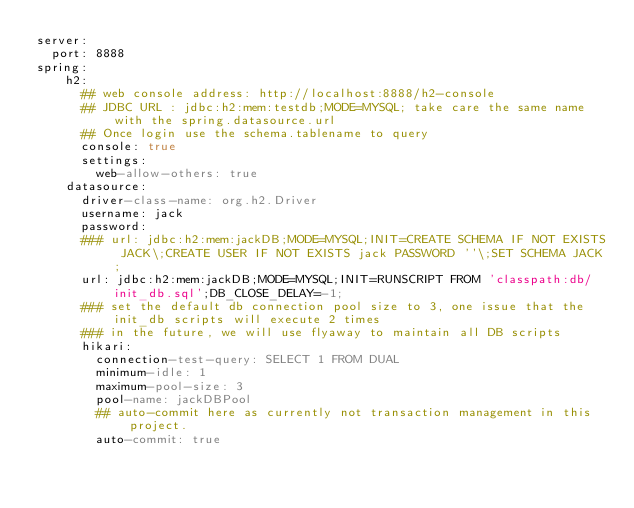Convert code to text. <code><loc_0><loc_0><loc_500><loc_500><_YAML_>server:
  port: 8888
spring:
    h2:
      ## web console address: http://localhost:8888/h2-console
      ## JDBC URL : jdbc:h2:mem:testdb;MODE=MYSQL; take care the same name with the spring.datasource.url
      ## Once login use the schema.tablename to query
      console: true
      settings:
        web-allow-others: true
    datasource:
      driver-class-name: org.h2.Driver
      username: jack
      password:
      ### url: jdbc:h2:mem:jackDB;MODE=MYSQL;INIT=CREATE SCHEMA IF NOT EXISTS JACK\;CREATE USER IF NOT EXISTS jack PASSWORD ''\;SET SCHEMA JACK;
      url: jdbc:h2:mem:jackDB;MODE=MYSQL;INIT=RUNSCRIPT FROM 'classpath:db/init_db.sql';DB_CLOSE_DELAY=-1;
      ### set the default db connection pool size to 3, one issue that the init_db scripts will execute 2 times
      ### in the future, we will use flyaway to maintain all DB scripts
      hikari:
        connection-test-query: SELECT 1 FROM DUAL
        minimum-idle: 1
        maximum-pool-size: 3
        pool-name: jackDBPool
        ## auto-commit here as currently not transaction management in this project.
        auto-commit: true</code> 